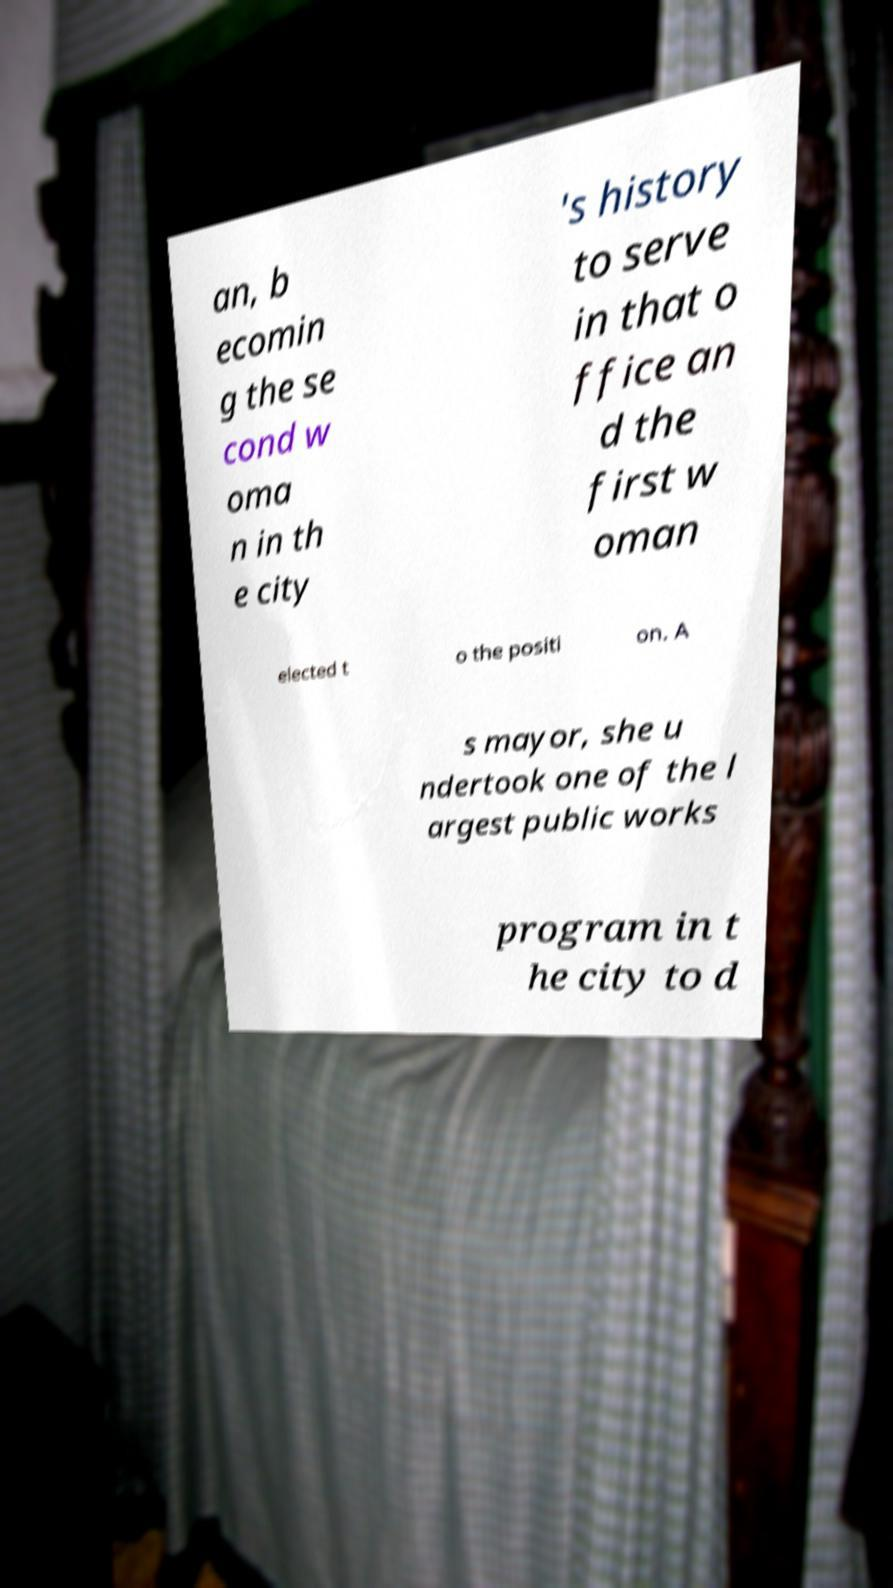Could you assist in decoding the text presented in this image and type it out clearly? an, b ecomin g the se cond w oma n in th e city 's history to serve in that o ffice an d the first w oman elected t o the positi on. A s mayor, she u ndertook one of the l argest public works program in t he city to d 